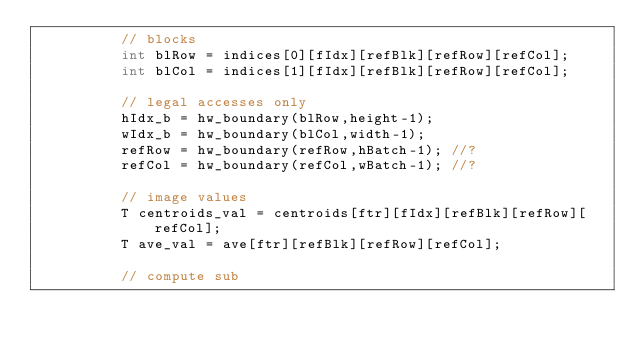Convert code to text. <code><loc_0><loc_0><loc_500><loc_500><_Cuda_>		  // blocks
		  int blRow = indices[0][fIdx][refBlk][refRow][refCol];
		  int blCol = indices[1][fIdx][refBlk][refRow][refCol];
    		    
		  // legal accesses only
		  hIdx_b = hw_boundary(blRow,height-1);
		  wIdx_b = hw_boundary(blCol,width-1);
		  refRow = hw_boundary(refRow,hBatch-1); //?
		  refCol = hw_boundary(refCol,wBatch-1); //?

		  // image values
		  T centroids_val = centroids[ftr][fIdx][refBlk][refRow][refCol];
		  T ave_val = ave[ftr][refBlk][refRow][refCol];

		  // compute sub </code> 